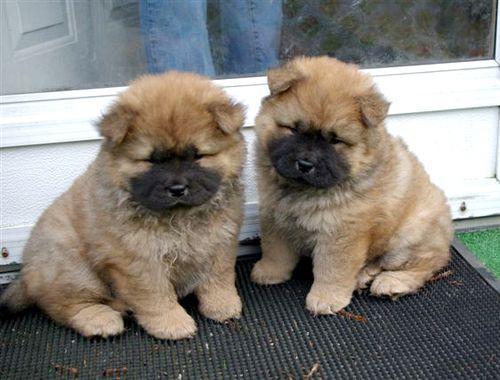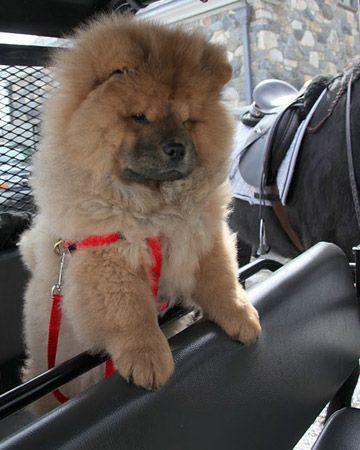The first image is the image on the left, the second image is the image on the right. Assess this claim about the two images: "Two dogs are sitting together in one of the images.". Correct or not? Answer yes or no. Yes. The first image is the image on the left, the second image is the image on the right. Evaluate the accuracy of this statement regarding the images: "In one image of a chow dog, a human leg in jeans is visible.". Is it true? Answer yes or no. Yes. 